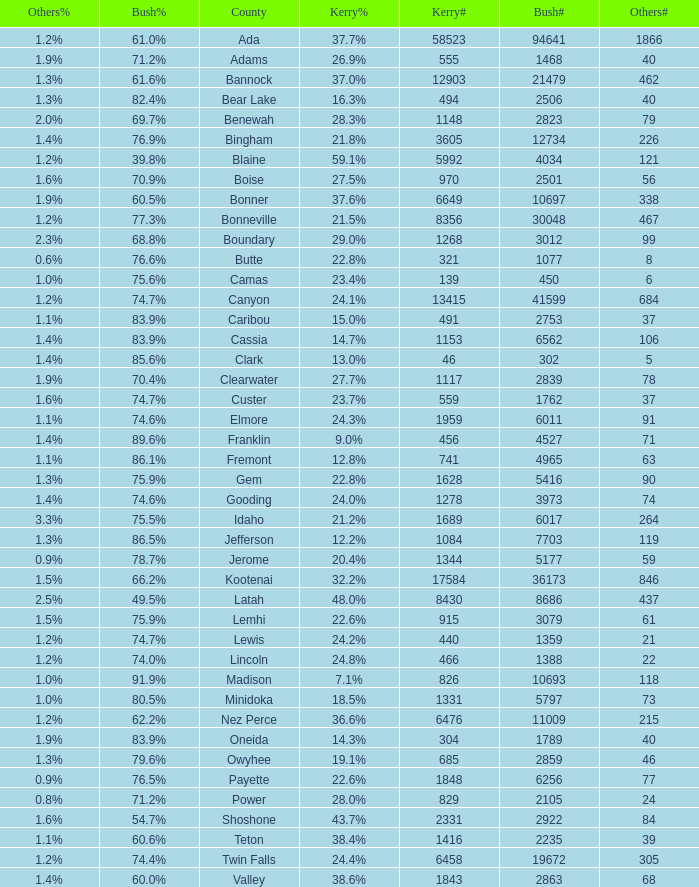What's percentage voted for Busg in the county where Kerry got 37.6%? 60.5%. 